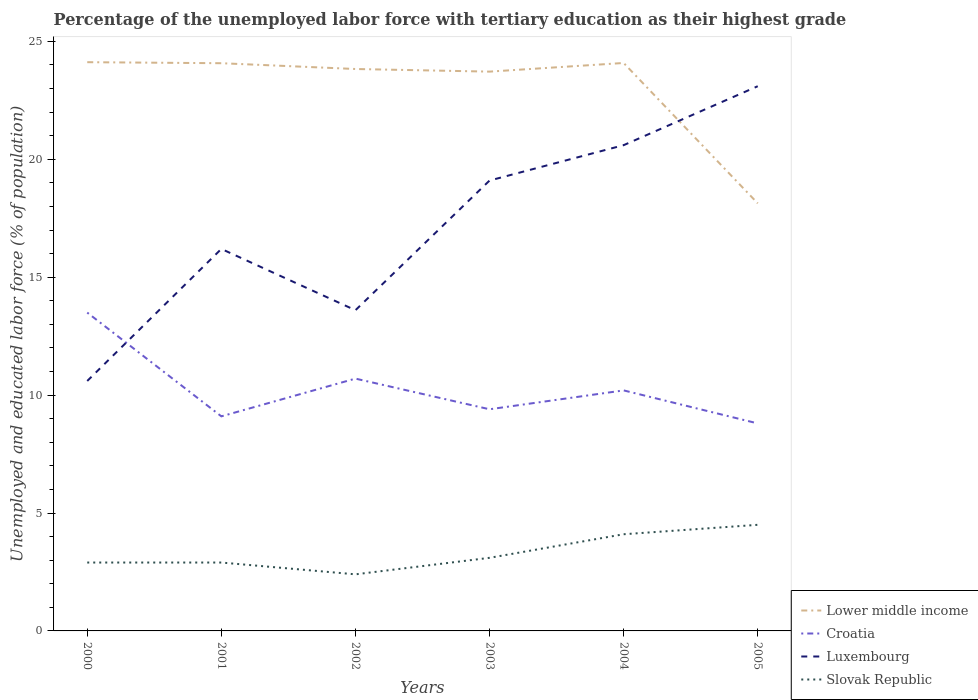How many different coloured lines are there?
Offer a terse response. 4. Across all years, what is the maximum percentage of the unemployed labor force with tertiary education in Luxembourg?
Keep it short and to the point. 10.6. What is the total percentage of the unemployed labor force with tertiary education in Lower middle income in the graph?
Keep it short and to the point. 5.99. What is the difference between the highest and the second highest percentage of the unemployed labor force with tertiary education in Luxembourg?
Give a very brief answer. 12.5. Is the percentage of the unemployed labor force with tertiary education in Slovak Republic strictly greater than the percentage of the unemployed labor force with tertiary education in Luxembourg over the years?
Your response must be concise. Yes. How many lines are there?
Keep it short and to the point. 4. How many years are there in the graph?
Give a very brief answer. 6. Are the values on the major ticks of Y-axis written in scientific E-notation?
Your answer should be very brief. No. Does the graph contain any zero values?
Provide a short and direct response. No. How many legend labels are there?
Offer a terse response. 4. What is the title of the graph?
Provide a short and direct response. Percentage of the unemployed labor force with tertiary education as their highest grade. What is the label or title of the X-axis?
Your answer should be compact. Years. What is the label or title of the Y-axis?
Your answer should be very brief. Unemployed and educated labor force (% of population). What is the Unemployed and educated labor force (% of population) of Lower middle income in 2000?
Offer a terse response. 24.12. What is the Unemployed and educated labor force (% of population) in Croatia in 2000?
Your answer should be compact. 13.5. What is the Unemployed and educated labor force (% of population) of Luxembourg in 2000?
Offer a very short reply. 10.6. What is the Unemployed and educated labor force (% of population) in Slovak Republic in 2000?
Your response must be concise. 2.9. What is the Unemployed and educated labor force (% of population) in Lower middle income in 2001?
Give a very brief answer. 24.08. What is the Unemployed and educated labor force (% of population) of Croatia in 2001?
Ensure brevity in your answer.  9.1. What is the Unemployed and educated labor force (% of population) in Luxembourg in 2001?
Give a very brief answer. 16.2. What is the Unemployed and educated labor force (% of population) of Slovak Republic in 2001?
Offer a terse response. 2.9. What is the Unemployed and educated labor force (% of population) of Lower middle income in 2002?
Make the answer very short. 23.83. What is the Unemployed and educated labor force (% of population) in Croatia in 2002?
Provide a succinct answer. 10.7. What is the Unemployed and educated labor force (% of population) in Luxembourg in 2002?
Your response must be concise. 13.6. What is the Unemployed and educated labor force (% of population) of Slovak Republic in 2002?
Your response must be concise. 2.4. What is the Unemployed and educated labor force (% of population) in Lower middle income in 2003?
Offer a very short reply. 23.72. What is the Unemployed and educated labor force (% of population) in Croatia in 2003?
Ensure brevity in your answer.  9.4. What is the Unemployed and educated labor force (% of population) of Luxembourg in 2003?
Make the answer very short. 19.1. What is the Unemployed and educated labor force (% of population) of Slovak Republic in 2003?
Keep it short and to the point. 3.1. What is the Unemployed and educated labor force (% of population) in Lower middle income in 2004?
Offer a terse response. 24.09. What is the Unemployed and educated labor force (% of population) of Croatia in 2004?
Provide a short and direct response. 10.2. What is the Unemployed and educated labor force (% of population) of Luxembourg in 2004?
Your answer should be compact. 20.6. What is the Unemployed and educated labor force (% of population) in Slovak Republic in 2004?
Your answer should be very brief. 4.1. What is the Unemployed and educated labor force (% of population) in Lower middle income in 2005?
Offer a terse response. 18.13. What is the Unemployed and educated labor force (% of population) in Croatia in 2005?
Provide a short and direct response. 8.8. What is the Unemployed and educated labor force (% of population) of Luxembourg in 2005?
Make the answer very short. 23.1. Across all years, what is the maximum Unemployed and educated labor force (% of population) in Lower middle income?
Ensure brevity in your answer.  24.12. Across all years, what is the maximum Unemployed and educated labor force (% of population) of Croatia?
Make the answer very short. 13.5. Across all years, what is the maximum Unemployed and educated labor force (% of population) of Luxembourg?
Keep it short and to the point. 23.1. Across all years, what is the maximum Unemployed and educated labor force (% of population) in Slovak Republic?
Ensure brevity in your answer.  4.5. Across all years, what is the minimum Unemployed and educated labor force (% of population) in Lower middle income?
Ensure brevity in your answer.  18.13. Across all years, what is the minimum Unemployed and educated labor force (% of population) of Croatia?
Your answer should be very brief. 8.8. Across all years, what is the minimum Unemployed and educated labor force (% of population) in Luxembourg?
Your answer should be compact. 10.6. Across all years, what is the minimum Unemployed and educated labor force (% of population) of Slovak Republic?
Provide a succinct answer. 2.4. What is the total Unemployed and educated labor force (% of population) of Lower middle income in the graph?
Provide a succinct answer. 137.96. What is the total Unemployed and educated labor force (% of population) of Croatia in the graph?
Provide a short and direct response. 61.7. What is the total Unemployed and educated labor force (% of population) in Luxembourg in the graph?
Offer a terse response. 103.2. What is the difference between the Unemployed and educated labor force (% of population) in Lower middle income in 2000 and that in 2001?
Your response must be concise. 0.04. What is the difference between the Unemployed and educated labor force (% of population) of Croatia in 2000 and that in 2001?
Your response must be concise. 4.4. What is the difference between the Unemployed and educated labor force (% of population) in Luxembourg in 2000 and that in 2001?
Give a very brief answer. -5.6. What is the difference between the Unemployed and educated labor force (% of population) of Slovak Republic in 2000 and that in 2001?
Your response must be concise. 0. What is the difference between the Unemployed and educated labor force (% of population) of Lower middle income in 2000 and that in 2002?
Keep it short and to the point. 0.29. What is the difference between the Unemployed and educated labor force (% of population) of Slovak Republic in 2000 and that in 2002?
Your response must be concise. 0.5. What is the difference between the Unemployed and educated labor force (% of population) of Lower middle income in 2000 and that in 2003?
Make the answer very short. 0.4. What is the difference between the Unemployed and educated labor force (% of population) of Croatia in 2000 and that in 2003?
Offer a very short reply. 4.1. What is the difference between the Unemployed and educated labor force (% of population) in Luxembourg in 2000 and that in 2003?
Offer a very short reply. -8.5. What is the difference between the Unemployed and educated labor force (% of population) in Lower middle income in 2000 and that in 2004?
Offer a very short reply. 0.03. What is the difference between the Unemployed and educated labor force (% of population) of Croatia in 2000 and that in 2004?
Your response must be concise. 3.3. What is the difference between the Unemployed and educated labor force (% of population) of Lower middle income in 2000 and that in 2005?
Offer a very short reply. 5.99. What is the difference between the Unemployed and educated labor force (% of population) of Croatia in 2000 and that in 2005?
Provide a short and direct response. 4.7. What is the difference between the Unemployed and educated labor force (% of population) in Slovak Republic in 2000 and that in 2005?
Your answer should be compact. -1.6. What is the difference between the Unemployed and educated labor force (% of population) in Lower middle income in 2001 and that in 2002?
Offer a terse response. 0.25. What is the difference between the Unemployed and educated labor force (% of population) in Croatia in 2001 and that in 2002?
Keep it short and to the point. -1.6. What is the difference between the Unemployed and educated labor force (% of population) of Slovak Republic in 2001 and that in 2002?
Your response must be concise. 0.5. What is the difference between the Unemployed and educated labor force (% of population) in Lower middle income in 2001 and that in 2003?
Keep it short and to the point. 0.36. What is the difference between the Unemployed and educated labor force (% of population) in Slovak Republic in 2001 and that in 2003?
Your response must be concise. -0.2. What is the difference between the Unemployed and educated labor force (% of population) in Lower middle income in 2001 and that in 2004?
Provide a succinct answer. -0.01. What is the difference between the Unemployed and educated labor force (% of population) of Croatia in 2001 and that in 2004?
Your response must be concise. -1.1. What is the difference between the Unemployed and educated labor force (% of population) in Lower middle income in 2001 and that in 2005?
Offer a very short reply. 5.94. What is the difference between the Unemployed and educated labor force (% of population) in Croatia in 2001 and that in 2005?
Keep it short and to the point. 0.3. What is the difference between the Unemployed and educated labor force (% of population) of Luxembourg in 2001 and that in 2005?
Your answer should be very brief. -6.9. What is the difference between the Unemployed and educated labor force (% of population) of Lower middle income in 2002 and that in 2003?
Ensure brevity in your answer.  0.11. What is the difference between the Unemployed and educated labor force (% of population) in Croatia in 2002 and that in 2003?
Provide a short and direct response. 1.3. What is the difference between the Unemployed and educated labor force (% of population) of Lower middle income in 2002 and that in 2004?
Your answer should be very brief. -0.26. What is the difference between the Unemployed and educated labor force (% of population) of Croatia in 2002 and that in 2004?
Make the answer very short. 0.5. What is the difference between the Unemployed and educated labor force (% of population) in Slovak Republic in 2002 and that in 2004?
Offer a terse response. -1.7. What is the difference between the Unemployed and educated labor force (% of population) of Lower middle income in 2002 and that in 2005?
Your answer should be very brief. 5.7. What is the difference between the Unemployed and educated labor force (% of population) in Croatia in 2002 and that in 2005?
Give a very brief answer. 1.9. What is the difference between the Unemployed and educated labor force (% of population) of Luxembourg in 2002 and that in 2005?
Give a very brief answer. -9.5. What is the difference between the Unemployed and educated labor force (% of population) of Slovak Republic in 2002 and that in 2005?
Provide a succinct answer. -2.1. What is the difference between the Unemployed and educated labor force (% of population) in Lower middle income in 2003 and that in 2004?
Provide a succinct answer. -0.37. What is the difference between the Unemployed and educated labor force (% of population) in Luxembourg in 2003 and that in 2004?
Offer a terse response. -1.5. What is the difference between the Unemployed and educated labor force (% of population) of Lower middle income in 2003 and that in 2005?
Make the answer very short. 5.59. What is the difference between the Unemployed and educated labor force (% of population) of Luxembourg in 2003 and that in 2005?
Ensure brevity in your answer.  -4. What is the difference between the Unemployed and educated labor force (% of population) of Slovak Republic in 2003 and that in 2005?
Your answer should be compact. -1.4. What is the difference between the Unemployed and educated labor force (% of population) of Lower middle income in 2004 and that in 2005?
Your response must be concise. 5.95. What is the difference between the Unemployed and educated labor force (% of population) of Slovak Republic in 2004 and that in 2005?
Your answer should be compact. -0.4. What is the difference between the Unemployed and educated labor force (% of population) in Lower middle income in 2000 and the Unemployed and educated labor force (% of population) in Croatia in 2001?
Ensure brevity in your answer.  15.02. What is the difference between the Unemployed and educated labor force (% of population) of Lower middle income in 2000 and the Unemployed and educated labor force (% of population) of Luxembourg in 2001?
Offer a very short reply. 7.92. What is the difference between the Unemployed and educated labor force (% of population) of Lower middle income in 2000 and the Unemployed and educated labor force (% of population) of Slovak Republic in 2001?
Ensure brevity in your answer.  21.22. What is the difference between the Unemployed and educated labor force (% of population) of Lower middle income in 2000 and the Unemployed and educated labor force (% of population) of Croatia in 2002?
Provide a succinct answer. 13.42. What is the difference between the Unemployed and educated labor force (% of population) in Lower middle income in 2000 and the Unemployed and educated labor force (% of population) in Luxembourg in 2002?
Your answer should be compact. 10.52. What is the difference between the Unemployed and educated labor force (% of population) in Lower middle income in 2000 and the Unemployed and educated labor force (% of population) in Slovak Republic in 2002?
Ensure brevity in your answer.  21.72. What is the difference between the Unemployed and educated labor force (% of population) of Croatia in 2000 and the Unemployed and educated labor force (% of population) of Luxembourg in 2002?
Your answer should be very brief. -0.1. What is the difference between the Unemployed and educated labor force (% of population) of Lower middle income in 2000 and the Unemployed and educated labor force (% of population) of Croatia in 2003?
Offer a terse response. 14.72. What is the difference between the Unemployed and educated labor force (% of population) in Lower middle income in 2000 and the Unemployed and educated labor force (% of population) in Luxembourg in 2003?
Give a very brief answer. 5.02. What is the difference between the Unemployed and educated labor force (% of population) in Lower middle income in 2000 and the Unemployed and educated labor force (% of population) in Slovak Republic in 2003?
Provide a short and direct response. 21.02. What is the difference between the Unemployed and educated labor force (% of population) in Croatia in 2000 and the Unemployed and educated labor force (% of population) in Slovak Republic in 2003?
Your answer should be very brief. 10.4. What is the difference between the Unemployed and educated labor force (% of population) in Luxembourg in 2000 and the Unemployed and educated labor force (% of population) in Slovak Republic in 2003?
Your answer should be compact. 7.5. What is the difference between the Unemployed and educated labor force (% of population) in Lower middle income in 2000 and the Unemployed and educated labor force (% of population) in Croatia in 2004?
Keep it short and to the point. 13.92. What is the difference between the Unemployed and educated labor force (% of population) in Lower middle income in 2000 and the Unemployed and educated labor force (% of population) in Luxembourg in 2004?
Keep it short and to the point. 3.52. What is the difference between the Unemployed and educated labor force (% of population) in Lower middle income in 2000 and the Unemployed and educated labor force (% of population) in Slovak Republic in 2004?
Offer a terse response. 20.02. What is the difference between the Unemployed and educated labor force (% of population) of Croatia in 2000 and the Unemployed and educated labor force (% of population) of Slovak Republic in 2004?
Offer a terse response. 9.4. What is the difference between the Unemployed and educated labor force (% of population) of Lower middle income in 2000 and the Unemployed and educated labor force (% of population) of Croatia in 2005?
Keep it short and to the point. 15.32. What is the difference between the Unemployed and educated labor force (% of population) in Lower middle income in 2000 and the Unemployed and educated labor force (% of population) in Luxembourg in 2005?
Provide a short and direct response. 1.02. What is the difference between the Unemployed and educated labor force (% of population) of Lower middle income in 2000 and the Unemployed and educated labor force (% of population) of Slovak Republic in 2005?
Offer a terse response. 19.62. What is the difference between the Unemployed and educated labor force (% of population) in Croatia in 2000 and the Unemployed and educated labor force (% of population) in Luxembourg in 2005?
Provide a succinct answer. -9.6. What is the difference between the Unemployed and educated labor force (% of population) in Lower middle income in 2001 and the Unemployed and educated labor force (% of population) in Croatia in 2002?
Offer a very short reply. 13.38. What is the difference between the Unemployed and educated labor force (% of population) in Lower middle income in 2001 and the Unemployed and educated labor force (% of population) in Luxembourg in 2002?
Offer a terse response. 10.48. What is the difference between the Unemployed and educated labor force (% of population) in Lower middle income in 2001 and the Unemployed and educated labor force (% of population) in Slovak Republic in 2002?
Provide a short and direct response. 21.68. What is the difference between the Unemployed and educated labor force (% of population) of Croatia in 2001 and the Unemployed and educated labor force (% of population) of Luxembourg in 2002?
Your answer should be very brief. -4.5. What is the difference between the Unemployed and educated labor force (% of population) of Lower middle income in 2001 and the Unemployed and educated labor force (% of population) of Croatia in 2003?
Your answer should be compact. 14.68. What is the difference between the Unemployed and educated labor force (% of population) of Lower middle income in 2001 and the Unemployed and educated labor force (% of population) of Luxembourg in 2003?
Make the answer very short. 4.98. What is the difference between the Unemployed and educated labor force (% of population) in Lower middle income in 2001 and the Unemployed and educated labor force (% of population) in Slovak Republic in 2003?
Offer a very short reply. 20.98. What is the difference between the Unemployed and educated labor force (% of population) in Croatia in 2001 and the Unemployed and educated labor force (% of population) in Luxembourg in 2003?
Provide a short and direct response. -10. What is the difference between the Unemployed and educated labor force (% of population) in Lower middle income in 2001 and the Unemployed and educated labor force (% of population) in Croatia in 2004?
Offer a terse response. 13.88. What is the difference between the Unemployed and educated labor force (% of population) of Lower middle income in 2001 and the Unemployed and educated labor force (% of population) of Luxembourg in 2004?
Give a very brief answer. 3.48. What is the difference between the Unemployed and educated labor force (% of population) in Lower middle income in 2001 and the Unemployed and educated labor force (% of population) in Slovak Republic in 2004?
Your response must be concise. 19.98. What is the difference between the Unemployed and educated labor force (% of population) in Luxembourg in 2001 and the Unemployed and educated labor force (% of population) in Slovak Republic in 2004?
Offer a very short reply. 12.1. What is the difference between the Unemployed and educated labor force (% of population) of Lower middle income in 2001 and the Unemployed and educated labor force (% of population) of Croatia in 2005?
Your answer should be compact. 15.28. What is the difference between the Unemployed and educated labor force (% of population) in Lower middle income in 2001 and the Unemployed and educated labor force (% of population) in Luxembourg in 2005?
Keep it short and to the point. 0.98. What is the difference between the Unemployed and educated labor force (% of population) in Lower middle income in 2001 and the Unemployed and educated labor force (% of population) in Slovak Republic in 2005?
Make the answer very short. 19.58. What is the difference between the Unemployed and educated labor force (% of population) of Croatia in 2001 and the Unemployed and educated labor force (% of population) of Slovak Republic in 2005?
Make the answer very short. 4.6. What is the difference between the Unemployed and educated labor force (% of population) in Lower middle income in 2002 and the Unemployed and educated labor force (% of population) in Croatia in 2003?
Keep it short and to the point. 14.43. What is the difference between the Unemployed and educated labor force (% of population) of Lower middle income in 2002 and the Unemployed and educated labor force (% of population) of Luxembourg in 2003?
Your answer should be very brief. 4.73. What is the difference between the Unemployed and educated labor force (% of population) of Lower middle income in 2002 and the Unemployed and educated labor force (% of population) of Slovak Republic in 2003?
Provide a succinct answer. 20.73. What is the difference between the Unemployed and educated labor force (% of population) of Luxembourg in 2002 and the Unemployed and educated labor force (% of population) of Slovak Republic in 2003?
Keep it short and to the point. 10.5. What is the difference between the Unemployed and educated labor force (% of population) of Lower middle income in 2002 and the Unemployed and educated labor force (% of population) of Croatia in 2004?
Make the answer very short. 13.63. What is the difference between the Unemployed and educated labor force (% of population) in Lower middle income in 2002 and the Unemployed and educated labor force (% of population) in Luxembourg in 2004?
Your answer should be very brief. 3.23. What is the difference between the Unemployed and educated labor force (% of population) in Lower middle income in 2002 and the Unemployed and educated labor force (% of population) in Slovak Republic in 2004?
Provide a succinct answer. 19.73. What is the difference between the Unemployed and educated labor force (% of population) in Croatia in 2002 and the Unemployed and educated labor force (% of population) in Slovak Republic in 2004?
Provide a short and direct response. 6.6. What is the difference between the Unemployed and educated labor force (% of population) in Lower middle income in 2002 and the Unemployed and educated labor force (% of population) in Croatia in 2005?
Your response must be concise. 15.03. What is the difference between the Unemployed and educated labor force (% of population) in Lower middle income in 2002 and the Unemployed and educated labor force (% of population) in Luxembourg in 2005?
Your answer should be compact. 0.73. What is the difference between the Unemployed and educated labor force (% of population) in Lower middle income in 2002 and the Unemployed and educated labor force (% of population) in Slovak Republic in 2005?
Give a very brief answer. 19.33. What is the difference between the Unemployed and educated labor force (% of population) in Croatia in 2002 and the Unemployed and educated labor force (% of population) in Luxembourg in 2005?
Provide a succinct answer. -12.4. What is the difference between the Unemployed and educated labor force (% of population) of Croatia in 2002 and the Unemployed and educated labor force (% of population) of Slovak Republic in 2005?
Your answer should be very brief. 6.2. What is the difference between the Unemployed and educated labor force (% of population) of Lower middle income in 2003 and the Unemployed and educated labor force (% of population) of Croatia in 2004?
Offer a very short reply. 13.52. What is the difference between the Unemployed and educated labor force (% of population) in Lower middle income in 2003 and the Unemployed and educated labor force (% of population) in Luxembourg in 2004?
Provide a short and direct response. 3.12. What is the difference between the Unemployed and educated labor force (% of population) in Lower middle income in 2003 and the Unemployed and educated labor force (% of population) in Slovak Republic in 2004?
Ensure brevity in your answer.  19.62. What is the difference between the Unemployed and educated labor force (% of population) in Croatia in 2003 and the Unemployed and educated labor force (% of population) in Luxembourg in 2004?
Offer a terse response. -11.2. What is the difference between the Unemployed and educated labor force (% of population) in Croatia in 2003 and the Unemployed and educated labor force (% of population) in Slovak Republic in 2004?
Give a very brief answer. 5.3. What is the difference between the Unemployed and educated labor force (% of population) of Lower middle income in 2003 and the Unemployed and educated labor force (% of population) of Croatia in 2005?
Offer a terse response. 14.92. What is the difference between the Unemployed and educated labor force (% of population) of Lower middle income in 2003 and the Unemployed and educated labor force (% of population) of Luxembourg in 2005?
Provide a short and direct response. 0.62. What is the difference between the Unemployed and educated labor force (% of population) of Lower middle income in 2003 and the Unemployed and educated labor force (% of population) of Slovak Republic in 2005?
Give a very brief answer. 19.22. What is the difference between the Unemployed and educated labor force (% of population) in Croatia in 2003 and the Unemployed and educated labor force (% of population) in Luxembourg in 2005?
Ensure brevity in your answer.  -13.7. What is the difference between the Unemployed and educated labor force (% of population) of Croatia in 2003 and the Unemployed and educated labor force (% of population) of Slovak Republic in 2005?
Your answer should be very brief. 4.9. What is the difference between the Unemployed and educated labor force (% of population) in Luxembourg in 2003 and the Unemployed and educated labor force (% of population) in Slovak Republic in 2005?
Offer a terse response. 14.6. What is the difference between the Unemployed and educated labor force (% of population) of Lower middle income in 2004 and the Unemployed and educated labor force (% of population) of Croatia in 2005?
Keep it short and to the point. 15.29. What is the difference between the Unemployed and educated labor force (% of population) in Lower middle income in 2004 and the Unemployed and educated labor force (% of population) in Luxembourg in 2005?
Offer a very short reply. 0.99. What is the difference between the Unemployed and educated labor force (% of population) of Lower middle income in 2004 and the Unemployed and educated labor force (% of population) of Slovak Republic in 2005?
Keep it short and to the point. 19.59. What is the difference between the Unemployed and educated labor force (% of population) of Luxembourg in 2004 and the Unemployed and educated labor force (% of population) of Slovak Republic in 2005?
Make the answer very short. 16.1. What is the average Unemployed and educated labor force (% of population) in Lower middle income per year?
Your response must be concise. 22.99. What is the average Unemployed and educated labor force (% of population) of Croatia per year?
Ensure brevity in your answer.  10.28. What is the average Unemployed and educated labor force (% of population) in Luxembourg per year?
Make the answer very short. 17.2. What is the average Unemployed and educated labor force (% of population) in Slovak Republic per year?
Your answer should be compact. 3.32. In the year 2000, what is the difference between the Unemployed and educated labor force (% of population) in Lower middle income and Unemployed and educated labor force (% of population) in Croatia?
Provide a short and direct response. 10.62. In the year 2000, what is the difference between the Unemployed and educated labor force (% of population) in Lower middle income and Unemployed and educated labor force (% of population) in Luxembourg?
Your response must be concise. 13.52. In the year 2000, what is the difference between the Unemployed and educated labor force (% of population) of Lower middle income and Unemployed and educated labor force (% of population) of Slovak Republic?
Offer a terse response. 21.22. In the year 2000, what is the difference between the Unemployed and educated labor force (% of population) in Croatia and Unemployed and educated labor force (% of population) in Luxembourg?
Your response must be concise. 2.9. In the year 2000, what is the difference between the Unemployed and educated labor force (% of population) in Croatia and Unemployed and educated labor force (% of population) in Slovak Republic?
Your response must be concise. 10.6. In the year 2001, what is the difference between the Unemployed and educated labor force (% of population) in Lower middle income and Unemployed and educated labor force (% of population) in Croatia?
Offer a terse response. 14.98. In the year 2001, what is the difference between the Unemployed and educated labor force (% of population) of Lower middle income and Unemployed and educated labor force (% of population) of Luxembourg?
Keep it short and to the point. 7.88. In the year 2001, what is the difference between the Unemployed and educated labor force (% of population) of Lower middle income and Unemployed and educated labor force (% of population) of Slovak Republic?
Offer a terse response. 21.18. In the year 2001, what is the difference between the Unemployed and educated labor force (% of population) in Croatia and Unemployed and educated labor force (% of population) in Luxembourg?
Ensure brevity in your answer.  -7.1. In the year 2002, what is the difference between the Unemployed and educated labor force (% of population) of Lower middle income and Unemployed and educated labor force (% of population) of Croatia?
Offer a very short reply. 13.13. In the year 2002, what is the difference between the Unemployed and educated labor force (% of population) in Lower middle income and Unemployed and educated labor force (% of population) in Luxembourg?
Your answer should be compact. 10.23. In the year 2002, what is the difference between the Unemployed and educated labor force (% of population) in Lower middle income and Unemployed and educated labor force (% of population) in Slovak Republic?
Make the answer very short. 21.43. In the year 2002, what is the difference between the Unemployed and educated labor force (% of population) in Luxembourg and Unemployed and educated labor force (% of population) in Slovak Republic?
Give a very brief answer. 11.2. In the year 2003, what is the difference between the Unemployed and educated labor force (% of population) of Lower middle income and Unemployed and educated labor force (% of population) of Croatia?
Your answer should be compact. 14.32. In the year 2003, what is the difference between the Unemployed and educated labor force (% of population) in Lower middle income and Unemployed and educated labor force (% of population) in Luxembourg?
Provide a succinct answer. 4.62. In the year 2003, what is the difference between the Unemployed and educated labor force (% of population) of Lower middle income and Unemployed and educated labor force (% of population) of Slovak Republic?
Give a very brief answer. 20.62. In the year 2003, what is the difference between the Unemployed and educated labor force (% of population) in Croatia and Unemployed and educated labor force (% of population) in Luxembourg?
Your response must be concise. -9.7. In the year 2003, what is the difference between the Unemployed and educated labor force (% of population) in Luxembourg and Unemployed and educated labor force (% of population) in Slovak Republic?
Your answer should be compact. 16. In the year 2004, what is the difference between the Unemployed and educated labor force (% of population) in Lower middle income and Unemployed and educated labor force (% of population) in Croatia?
Ensure brevity in your answer.  13.89. In the year 2004, what is the difference between the Unemployed and educated labor force (% of population) of Lower middle income and Unemployed and educated labor force (% of population) of Luxembourg?
Your answer should be compact. 3.49. In the year 2004, what is the difference between the Unemployed and educated labor force (% of population) in Lower middle income and Unemployed and educated labor force (% of population) in Slovak Republic?
Your response must be concise. 19.99. In the year 2004, what is the difference between the Unemployed and educated labor force (% of population) in Croatia and Unemployed and educated labor force (% of population) in Luxembourg?
Provide a succinct answer. -10.4. In the year 2004, what is the difference between the Unemployed and educated labor force (% of population) in Luxembourg and Unemployed and educated labor force (% of population) in Slovak Republic?
Your answer should be compact. 16.5. In the year 2005, what is the difference between the Unemployed and educated labor force (% of population) in Lower middle income and Unemployed and educated labor force (% of population) in Croatia?
Your answer should be very brief. 9.33. In the year 2005, what is the difference between the Unemployed and educated labor force (% of population) of Lower middle income and Unemployed and educated labor force (% of population) of Luxembourg?
Give a very brief answer. -4.97. In the year 2005, what is the difference between the Unemployed and educated labor force (% of population) in Lower middle income and Unemployed and educated labor force (% of population) in Slovak Republic?
Provide a succinct answer. 13.63. In the year 2005, what is the difference between the Unemployed and educated labor force (% of population) of Croatia and Unemployed and educated labor force (% of population) of Luxembourg?
Give a very brief answer. -14.3. What is the ratio of the Unemployed and educated labor force (% of population) in Croatia in 2000 to that in 2001?
Your response must be concise. 1.48. What is the ratio of the Unemployed and educated labor force (% of population) of Luxembourg in 2000 to that in 2001?
Ensure brevity in your answer.  0.65. What is the ratio of the Unemployed and educated labor force (% of population) of Lower middle income in 2000 to that in 2002?
Keep it short and to the point. 1.01. What is the ratio of the Unemployed and educated labor force (% of population) in Croatia in 2000 to that in 2002?
Provide a succinct answer. 1.26. What is the ratio of the Unemployed and educated labor force (% of population) of Luxembourg in 2000 to that in 2002?
Keep it short and to the point. 0.78. What is the ratio of the Unemployed and educated labor force (% of population) of Slovak Republic in 2000 to that in 2002?
Offer a terse response. 1.21. What is the ratio of the Unemployed and educated labor force (% of population) in Lower middle income in 2000 to that in 2003?
Make the answer very short. 1.02. What is the ratio of the Unemployed and educated labor force (% of population) of Croatia in 2000 to that in 2003?
Make the answer very short. 1.44. What is the ratio of the Unemployed and educated labor force (% of population) of Luxembourg in 2000 to that in 2003?
Offer a terse response. 0.56. What is the ratio of the Unemployed and educated labor force (% of population) in Slovak Republic in 2000 to that in 2003?
Provide a short and direct response. 0.94. What is the ratio of the Unemployed and educated labor force (% of population) of Croatia in 2000 to that in 2004?
Provide a short and direct response. 1.32. What is the ratio of the Unemployed and educated labor force (% of population) in Luxembourg in 2000 to that in 2004?
Keep it short and to the point. 0.51. What is the ratio of the Unemployed and educated labor force (% of population) in Slovak Republic in 2000 to that in 2004?
Keep it short and to the point. 0.71. What is the ratio of the Unemployed and educated labor force (% of population) of Lower middle income in 2000 to that in 2005?
Give a very brief answer. 1.33. What is the ratio of the Unemployed and educated labor force (% of population) in Croatia in 2000 to that in 2005?
Offer a terse response. 1.53. What is the ratio of the Unemployed and educated labor force (% of population) in Luxembourg in 2000 to that in 2005?
Ensure brevity in your answer.  0.46. What is the ratio of the Unemployed and educated labor force (% of population) of Slovak Republic in 2000 to that in 2005?
Make the answer very short. 0.64. What is the ratio of the Unemployed and educated labor force (% of population) of Lower middle income in 2001 to that in 2002?
Ensure brevity in your answer.  1.01. What is the ratio of the Unemployed and educated labor force (% of population) in Croatia in 2001 to that in 2002?
Offer a terse response. 0.85. What is the ratio of the Unemployed and educated labor force (% of population) of Luxembourg in 2001 to that in 2002?
Offer a very short reply. 1.19. What is the ratio of the Unemployed and educated labor force (% of population) of Slovak Republic in 2001 to that in 2002?
Make the answer very short. 1.21. What is the ratio of the Unemployed and educated labor force (% of population) in Croatia in 2001 to that in 2003?
Your response must be concise. 0.97. What is the ratio of the Unemployed and educated labor force (% of population) in Luxembourg in 2001 to that in 2003?
Your response must be concise. 0.85. What is the ratio of the Unemployed and educated labor force (% of population) in Slovak Republic in 2001 to that in 2003?
Your answer should be very brief. 0.94. What is the ratio of the Unemployed and educated labor force (% of population) of Croatia in 2001 to that in 2004?
Keep it short and to the point. 0.89. What is the ratio of the Unemployed and educated labor force (% of population) of Luxembourg in 2001 to that in 2004?
Offer a very short reply. 0.79. What is the ratio of the Unemployed and educated labor force (% of population) of Slovak Republic in 2001 to that in 2004?
Offer a terse response. 0.71. What is the ratio of the Unemployed and educated labor force (% of population) of Lower middle income in 2001 to that in 2005?
Your response must be concise. 1.33. What is the ratio of the Unemployed and educated labor force (% of population) of Croatia in 2001 to that in 2005?
Make the answer very short. 1.03. What is the ratio of the Unemployed and educated labor force (% of population) in Luxembourg in 2001 to that in 2005?
Your answer should be compact. 0.7. What is the ratio of the Unemployed and educated labor force (% of population) in Slovak Republic in 2001 to that in 2005?
Give a very brief answer. 0.64. What is the ratio of the Unemployed and educated labor force (% of population) in Lower middle income in 2002 to that in 2003?
Your answer should be very brief. 1. What is the ratio of the Unemployed and educated labor force (% of population) of Croatia in 2002 to that in 2003?
Provide a short and direct response. 1.14. What is the ratio of the Unemployed and educated labor force (% of population) in Luxembourg in 2002 to that in 2003?
Your response must be concise. 0.71. What is the ratio of the Unemployed and educated labor force (% of population) in Slovak Republic in 2002 to that in 2003?
Your answer should be very brief. 0.77. What is the ratio of the Unemployed and educated labor force (% of population) in Lower middle income in 2002 to that in 2004?
Offer a very short reply. 0.99. What is the ratio of the Unemployed and educated labor force (% of population) of Croatia in 2002 to that in 2004?
Make the answer very short. 1.05. What is the ratio of the Unemployed and educated labor force (% of population) in Luxembourg in 2002 to that in 2004?
Your answer should be compact. 0.66. What is the ratio of the Unemployed and educated labor force (% of population) of Slovak Republic in 2002 to that in 2004?
Ensure brevity in your answer.  0.59. What is the ratio of the Unemployed and educated labor force (% of population) of Lower middle income in 2002 to that in 2005?
Your answer should be compact. 1.31. What is the ratio of the Unemployed and educated labor force (% of population) of Croatia in 2002 to that in 2005?
Keep it short and to the point. 1.22. What is the ratio of the Unemployed and educated labor force (% of population) of Luxembourg in 2002 to that in 2005?
Offer a very short reply. 0.59. What is the ratio of the Unemployed and educated labor force (% of population) of Slovak Republic in 2002 to that in 2005?
Provide a short and direct response. 0.53. What is the ratio of the Unemployed and educated labor force (% of population) of Lower middle income in 2003 to that in 2004?
Your response must be concise. 0.98. What is the ratio of the Unemployed and educated labor force (% of population) in Croatia in 2003 to that in 2004?
Keep it short and to the point. 0.92. What is the ratio of the Unemployed and educated labor force (% of population) of Luxembourg in 2003 to that in 2004?
Give a very brief answer. 0.93. What is the ratio of the Unemployed and educated labor force (% of population) in Slovak Republic in 2003 to that in 2004?
Your answer should be compact. 0.76. What is the ratio of the Unemployed and educated labor force (% of population) of Lower middle income in 2003 to that in 2005?
Your response must be concise. 1.31. What is the ratio of the Unemployed and educated labor force (% of population) in Croatia in 2003 to that in 2005?
Your response must be concise. 1.07. What is the ratio of the Unemployed and educated labor force (% of population) of Luxembourg in 2003 to that in 2005?
Offer a very short reply. 0.83. What is the ratio of the Unemployed and educated labor force (% of population) of Slovak Republic in 2003 to that in 2005?
Make the answer very short. 0.69. What is the ratio of the Unemployed and educated labor force (% of population) of Lower middle income in 2004 to that in 2005?
Give a very brief answer. 1.33. What is the ratio of the Unemployed and educated labor force (% of population) in Croatia in 2004 to that in 2005?
Your answer should be very brief. 1.16. What is the ratio of the Unemployed and educated labor force (% of population) of Luxembourg in 2004 to that in 2005?
Make the answer very short. 0.89. What is the ratio of the Unemployed and educated labor force (% of population) of Slovak Republic in 2004 to that in 2005?
Ensure brevity in your answer.  0.91. What is the difference between the highest and the second highest Unemployed and educated labor force (% of population) of Lower middle income?
Your answer should be compact. 0.03. What is the difference between the highest and the second highest Unemployed and educated labor force (% of population) of Croatia?
Offer a very short reply. 2.8. What is the difference between the highest and the lowest Unemployed and educated labor force (% of population) in Lower middle income?
Your answer should be very brief. 5.99. What is the difference between the highest and the lowest Unemployed and educated labor force (% of population) in Croatia?
Offer a very short reply. 4.7. What is the difference between the highest and the lowest Unemployed and educated labor force (% of population) of Luxembourg?
Your response must be concise. 12.5. 